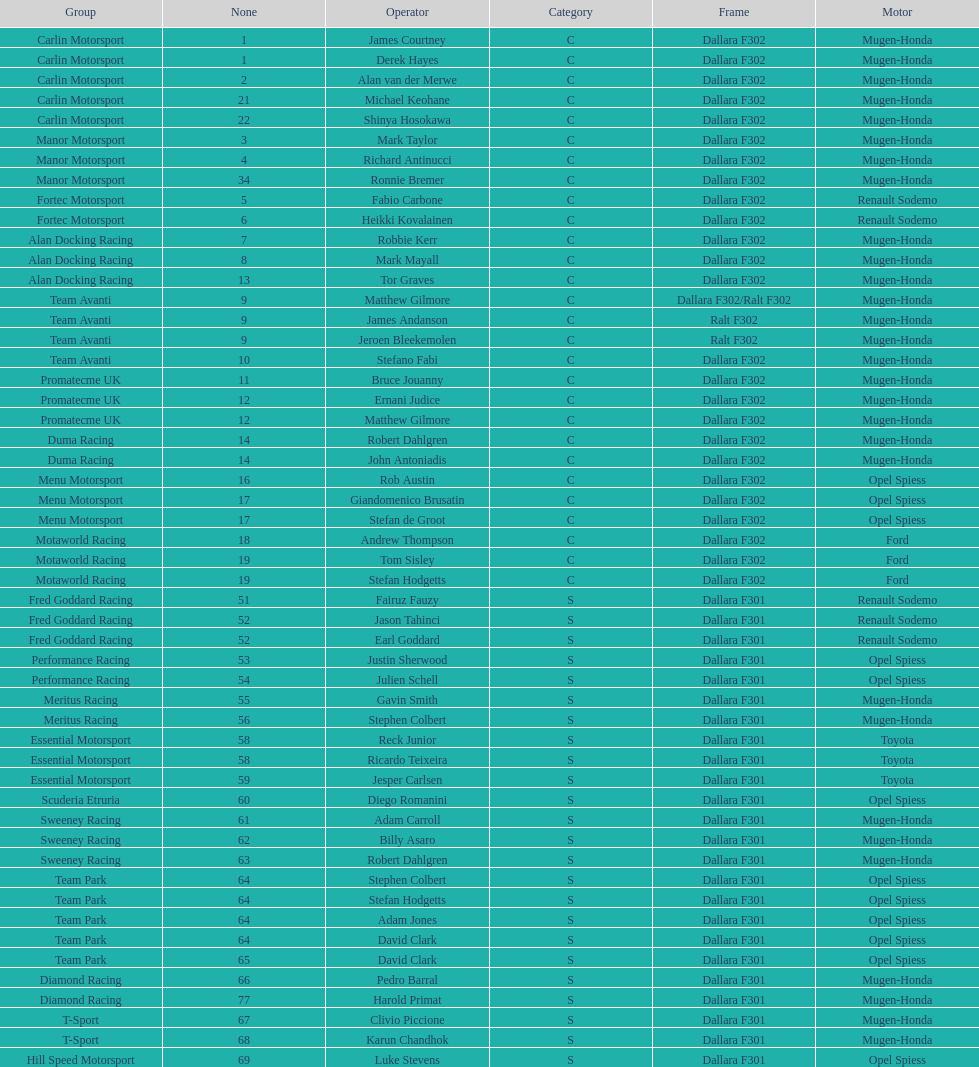Which engine was used the most by teams this season? Mugen-Honda. 